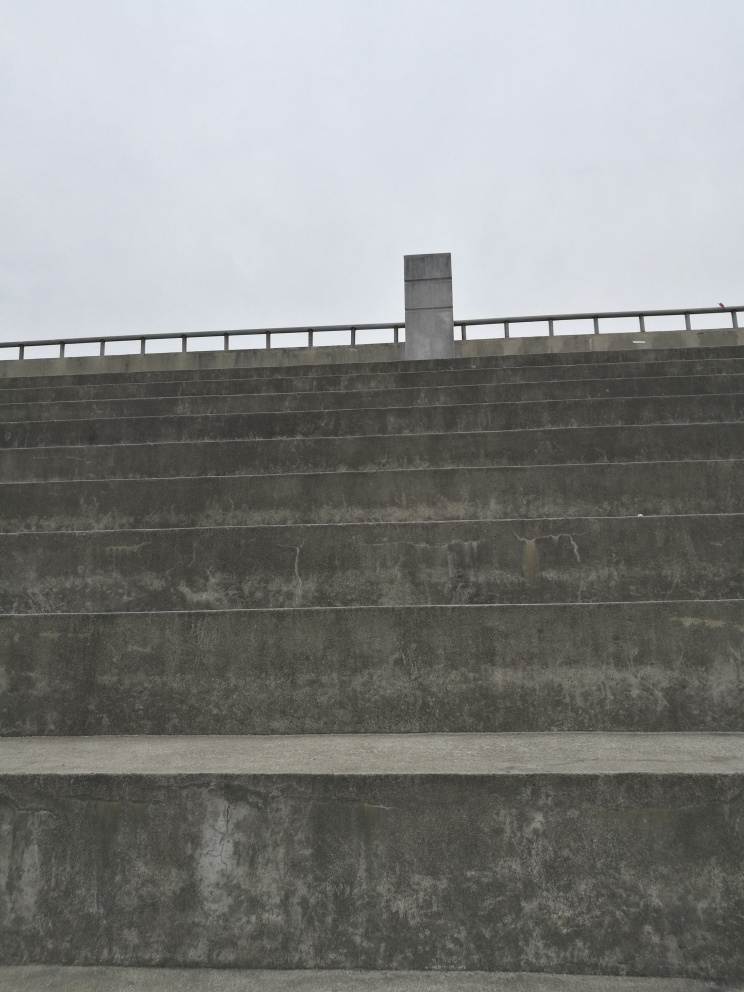How would you describe the clarity of the image?
A. blurry
B. good clarity
C. average clarity
Answer with the option's letter from the given choices directly.
 B. 